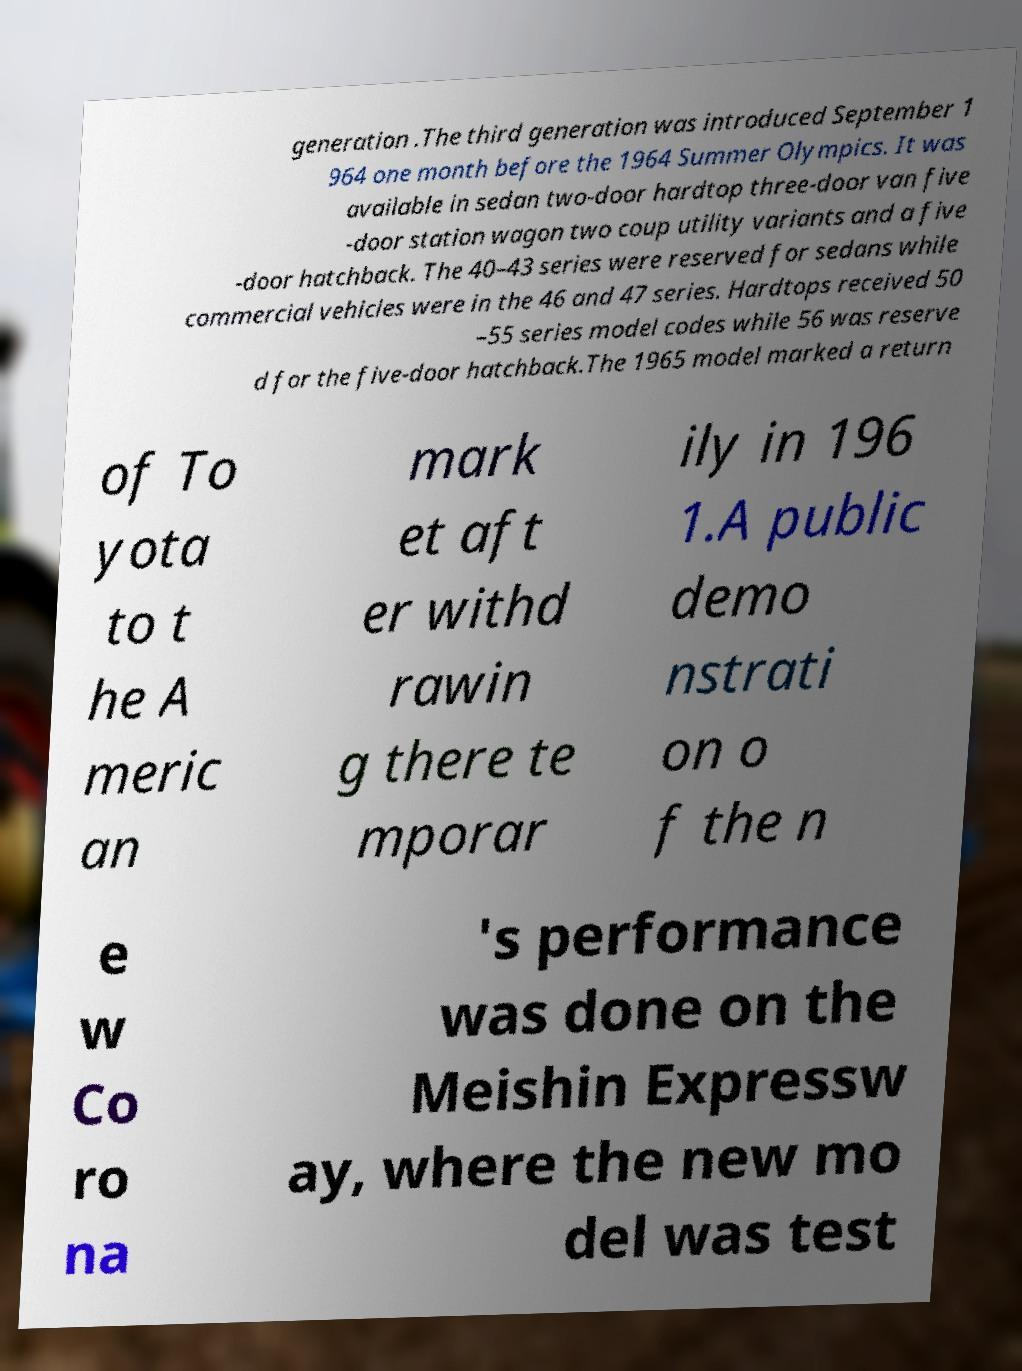Please identify and transcribe the text found in this image. generation .The third generation was introduced September 1 964 one month before the 1964 Summer Olympics. It was available in sedan two-door hardtop three-door van five -door station wagon two coup utility variants and a five -door hatchback. The 40–43 series were reserved for sedans while commercial vehicles were in the 46 and 47 series. Hardtops received 50 –55 series model codes while 56 was reserve d for the five-door hatchback.The 1965 model marked a return of To yota to t he A meric an mark et aft er withd rawin g there te mporar ily in 196 1.A public demo nstrati on o f the n e w Co ro na 's performance was done on the Meishin Expressw ay, where the new mo del was test 